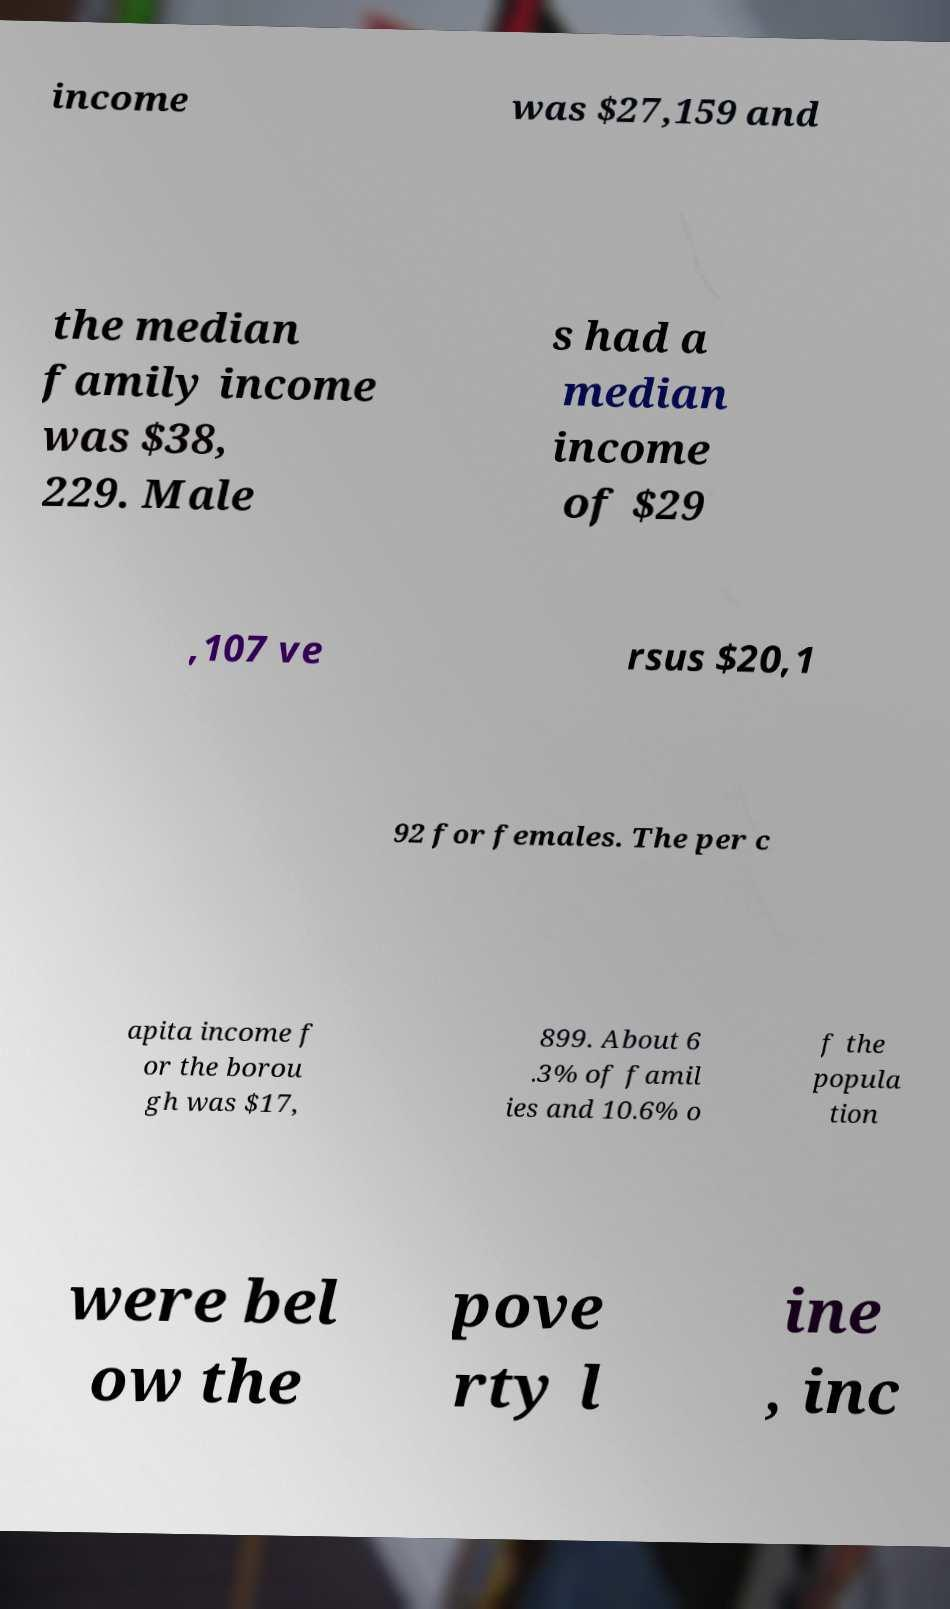Please read and relay the text visible in this image. What does it say? income was $27,159 and the median family income was $38, 229. Male s had a median income of $29 ,107 ve rsus $20,1 92 for females. The per c apita income f or the borou gh was $17, 899. About 6 .3% of famil ies and 10.6% o f the popula tion were bel ow the pove rty l ine , inc 